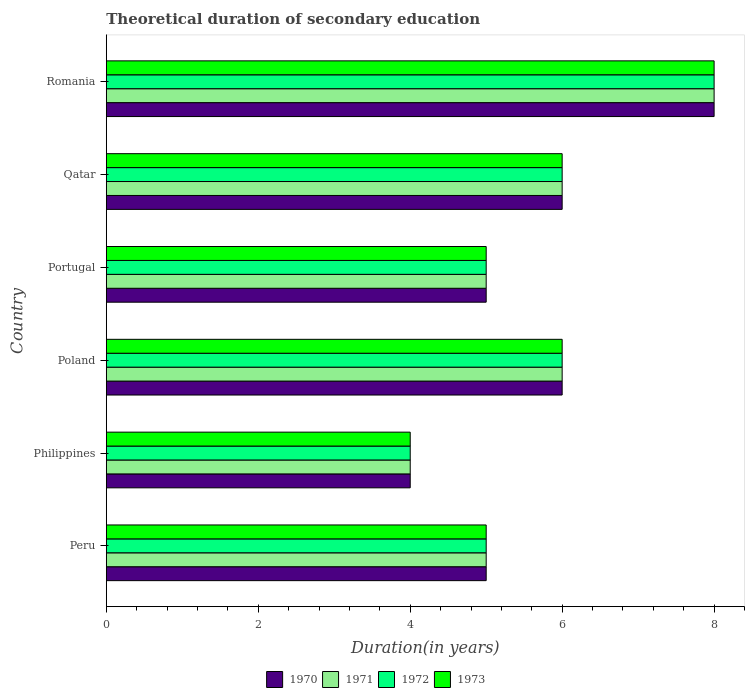How many groups of bars are there?
Provide a short and direct response. 6. Are the number of bars per tick equal to the number of legend labels?
Give a very brief answer. Yes. Are the number of bars on each tick of the Y-axis equal?
Give a very brief answer. Yes. How many bars are there on the 2nd tick from the bottom?
Make the answer very short. 4. What is the label of the 6th group of bars from the top?
Keep it short and to the point. Peru. What is the total theoretical duration of secondary education in 1973 in Poland?
Provide a short and direct response. 6. In which country was the total theoretical duration of secondary education in 1973 maximum?
Provide a short and direct response. Romania. What is the total total theoretical duration of secondary education in 1970 in the graph?
Offer a terse response. 34. What is the difference between the total theoretical duration of secondary education in 1972 in Philippines and that in Qatar?
Your answer should be very brief. -2. What is the difference between the total theoretical duration of secondary education in 1972 in Romania and the total theoretical duration of secondary education in 1971 in Philippines?
Offer a terse response. 4. What is the average total theoretical duration of secondary education in 1971 per country?
Make the answer very short. 5.67. What is the ratio of the total theoretical duration of secondary education in 1972 in Poland to that in Qatar?
Keep it short and to the point. 1. Is the total theoretical duration of secondary education in 1971 in Qatar less than that in Romania?
Your answer should be very brief. Yes. Is the difference between the total theoretical duration of secondary education in 1971 in Philippines and Poland greater than the difference between the total theoretical duration of secondary education in 1972 in Philippines and Poland?
Provide a succinct answer. No. What is the difference between the highest and the second highest total theoretical duration of secondary education in 1971?
Give a very brief answer. 2. What is the difference between the highest and the lowest total theoretical duration of secondary education in 1972?
Give a very brief answer. 4. Is the sum of the total theoretical duration of secondary education in 1973 in Poland and Romania greater than the maximum total theoretical duration of secondary education in 1972 across all countries?
Offer a terse response. Yes. Is it the case that in every country, the sum of the total theoretical duration of secondary education in 1970 and total theoretical duration of secondary education in 1971 is greater than the sum of total theoretical duration of secondary education in 1973 and total theoretical duration of secondary education in 1972?
Give a very brief answer. No. What does the 4th bar from the top in Philippines represents?
Your answer should be compact. 1970. What does the 1st bar from the bottom in Portugal represents?
Provide a short and direct response. 1970. Are all the bars in the graph horizontal?
Your response must be concise. Yes. How many countries are there in the graph?
Provide a succinct answer. 6. What is the difference between two consecutive major ticks on the X-axis?
Your answer should be compact. 2. Where does the legend appear in the graph?
Your answer should be compact. Bottom center. How many legend labels are there?
Offer a terse response. 4. How are the legend labels stacked?
Your response must be concise. Horizontal. What is the title of the graph?
Offer a terse response. Theoretical duration of secondary education. Does "1963" appear as one of the legend labels in the graph?
Provide a succinct answer. No. What is the label or title of the X-axis?
Offer a terse response. Duration(in years). What is the label or title of the Y-axis?
Provide a short and direct response. Country. What is the Duration(in years) in 1970 in Peru?
Offer a terse response. 5. What is the Duration(in years) of 1972 in Peru?
Keep it short and to the point. 5. What is the Duration(in years) of 1972 in Philippines?
Keep it short and to the point. 4. What is the Duration(in years) of 1971 in Poland?
Ensure brevity in your answer.  6. What is the Duration(in years) in 1970 in Portugal?
Your answer should be very brief. 5. What is the Duration(in years) in 1971 in Portugal?
Make the answer very short. 5. What is the Duration(in years) of 1973 in Portugal?
Your answer should be very brief. 5. What is the Duration(in years) in 1970 in Qatar?
Give a very brief answer. 6. What is the Duration(in years) of 1971 in Qatar?
Make the answer very short. 6. What is the Duration(in years) in 1972 in Qatar?
Make the answer very short. 6. What is the Duration(in years) of 1971 in Romania?
Keep it short and to the point. 8. What is the Duration(in years) of 1972 in Romania?
Your response must be concise. 8. Across all countries, what is the maximum Duration(in years) in 1972?
Offer a terse response. 8. Across all countries, what is the minimum Duration(in years) of 1970?
Ensure brevity in your answer.  4. Across all countries, what is the minimum Duration(in years) in 1971?
Provide a succinct answer. 4. Across all countries, what is the minimum Duration(in years) of 1972?
Provide a succinct answer. 4. Across all countries, what is the minimum Duration(in years) in 1973?
Keep it short and to the point. 4. What is the total Duration(in years) in 1971 in the graph?
Keep it short and to the point. 34. What is the total Duration(in years) in 1972 in the graph?
Provide a short and direct response. 34. What is the difference between the Duration(in years) in 1970 in Peru and that in Philippines?
Your answer should be very brief. 1. What is the difference between the Duration(in years) in 1972 in Peru and that in Philippines?
Provide a short and direct response. 1. What is the difference between the Duration(in years) of 1970 in Peru and that in Poland?
Ensure brevity in your answer.  -1. What is the difference between the Duration(in years) in 1971 in Peru and that in Poland?
Your response must be concise. -1. What is the difference between the Duration(in years) of 1973 in Peru and that in Poland?
Your answer should be very brief. -1. What is the difference between the Duration(in years) of 1970 in Peru and that in Portugal?
Make the answer very short. 0. What is the difference between the Duration(in years) of 1971 in Peru and that in Portugal?
Your answer should be compact. 0. What is the difference between the Duration(in years) in 1972 in Peru and that in Portugal?
Your answer should be very brief. 0. What is the difference between the Duration(in years) of 1971 in Peru and that in Qatar?
Provide a short and direct response. -1. What is the difference between the Duration(in years) of 1972 in Peru and that in Qatar?
Your answer should be very brief. -1. What is the difference between the Duration(in years) of 1970 in Peru and that in Romania?
Your answer should be compact. -3. What is the difference between the Duration(in years) in 1973 in Peru and that in Romania?
Your answer should be compact. -3. What is the difference between the Duration(in years) in 1972 in Philippines and that in Poland?
Provide a short and direct response. -2. What is the difference between the Duration(in years) in 1973 in Philippines and that in Poland?
Make the answer very short. -2. What is the difference between the Duration(in years) in 1970 in Philippines and that in Portugal?
Make the answer very short. -1. What is the difference between the Duration(in years) in 1972 in Philippines and that in Portugal?
Ensure brevity in your answer.  -1. What is the difference between the Duration(in years) of 1972 in Philippines and that in Qatar?
Provide a succinct answer. -2. What is the difference between the Duration(in years) of 1973 in Philippines and that in Qatar?
Keep it short and to the point. -2. What is the difference between the Duration(in years) of 1970 in Philippines and that in Romania?
Ensure brevity in your answer.  -4. What is the difference between the Duration(in years) in 1973 in Philippines and that in Romania?
Provide a short and direct response. -4. What is the difference between the Duration(in years) in 1971 in Poland and that in Qatar?
Give a very brief answer. 0. What is the difference between the Duration(in years) in 1971 in Poland and that in Romania?
Provide a short and direct response. -2. What is the difference between the Duration(in years) of 1971 in Portugal and that in Qatar?
Make the answer very short. -1. What is the difference between the Duration(in years) in 1970 in Portugal and that in Romania?
Make the answer very short. -3. What is the difference between the Duration(in years) in 1973 in Portugal and that in Romania?
Your response must be concise. -3. What is the difference between the Duration(in years) of 1971 in Peru and the Duration(in years) of 1973 in Philippines?
Provide a short and direct response. 1. What is the difference between the Duration(in years) in 1972 in Peru and the Duration(in years) in 1973 in Philippines?
Your response must be concise. 1. What is the difference between the Duration(in years) in 1970 in Peru and the Duration(in years) in 1972 in Poland?
Your response must be concise. -1. What is the difference between the Duration(in years) of 1970 in Peru and the Duration(in years) of 1971 in Portugal?
Offer a terse response. 0. What is the difference between the Duration(in years) in 1970 in Peru and the Duration(in years) in 1973 in Portugal?
Keep it short and to the point. 0. What is the difference between the Duration(in years) of 1971 in Peru and the Duration(in years) of 1972 in Portugal?
Your response must be concise. 0. What is the difference between the Duration(in years) in 1971 in Peru and the Duration(in years) in 1973 in Portugal?
Provide a short and direct response. 0. What is the difference between the Duration(in years) in 1972 in Peru and the Duration(in years) in 1973 in Portugal?
Offer a terse response. 0. What is the difference between the Duration(in years) of 1970 in Peru and the Duration(in years) of 1972 in Qatar?
Your answer should be very brief. -1. What is the difference between the Duration(in years) in 1970 in Peru and the Duration(in years) in 1973 in Qatar?
Keep it short and to the point. -1. What is the difference between the Duration(in years) of 1971 in Peru and the Duration(in years) of 1972 in Qatar?
Give a very brief answer. -1. What is the difference between the Duration(in years) in 1971 in Peru and the Duration(in years) in 1973 in Qatar?
Make the answer very short. -1. What is the difference between the Duration(in years) in 1972 in Peru and the Duration(in years) in 1973 in Qatar?
Your answer should be compact. -1. What is the difference between the Duration(in years) in 1970 in Peru and the Duration(in years) in 1972 in Romania?
Offer a terse response. -3. What is the difference between the Duration(in years) of 1970 in Peru and the Duration(in years) of 1973 in Romania?
Provide a succinct answer. -3. What is the difference between the Duration(in years) of 1971 in Peru and the Duration(in years) of 1973 in Romania?
Your answer should be compact. -3. What is the difference between the Duration(in years) of 1972 in Peru and the Duration(in years) of 1973 in Romania?
Your response must be concise. -3. What is the difference between the Duration(in years) of 1970 in Philippines and the Duration(in years) of 1971 in Poland?
Provide a short and direct response. -2. What is the difference between the Duration(in years) in 1970 in Philippines and the Duration(in years) in 1972 in Poland?
Your response must be concise. -2. What is the difference between the Duration(in years) in 1970 in Philippines and the Duration(in years) in 1973 in Poland?
Provide a succinct answer. -2. What is the difference between the Duration(in years) of 1971 in Philippines and the Duration(in years) of 1973 in Poland?
Offer a terse response. -2. What is the difference between the Duration(in years) of 1972 in Philippines and the Duration(in years) of 1973 in Poland?
Provide a succinct answer. -2. What is the difference between the Duration(in years) in 1970 in Philippines and the Duration(in years) in 1973 in Portugal?
Your answer should be compact. -1. What is the difference between the Duration(in years) of 1971 in Philippines and the Duration(in years) of 1973 in Portugal?
Your answer should be compact. -1. What is the difference between the Duration(in years) of 1970 in Philippines and the Duration(in years) of 1971 in Qatar?
Offer a very short reply. -2. What is the difference between the Duration(in years) in 1970 in Philippines and the Duration(in years) in 1973 in Qatar?
Keep it short and to the point. -2. What is the difference between the Duration(in years) of 1971 in Philippines and the Duration(in years) of 1972 in Qatar?
Your answer should be compact. -2. What is the difference between the Duration(in years) of 1970 in Philippines and the Duration(in years) of 1971 in Romania?
Offer a terse response. -4. What is the difference between the Duration(in years) of 1970 in Philippines and the Duration(in years) of 1973 in Romania?
Offer a terse response. -4. What is the difference between the Duration(in years) of 1971 in Philippines and the Duration(in years) of 1973 in Romania?
Provide a succinct answer. -4. What is the difference between the Duration(in years) in 1970 in Poland and the Duration(in years) in 1972 in Portugal?
Ensure brevity in your answer.  1. What is the difference between the Duration(in years) of 1970 in Poland and the Duration(in years) of 1973 in Portugal?
Provide a short and direct response. 1. What is the difference between the Duration(in years) of 1972 in Poland and the Duration(in years) of 1973 in Portugal?
Your answer should be compact. 1. What is the difference between the Duration(in years) in 1970 in Poland and the Duration(in years) in 1971 in Qatar?
Offer a terse response. 0. What is the difference between the Duration(in years) in 1971 in Poland and the Duration(in years) in 1973 in Qatar?
Your response must be concise. 0. What is the difference between the Duration(in years) of 1970 in Poland and the Duration(in years) of 1971 in Romania?
Keep it short and to the point. -2. What is the difference between the Duration(in years) of 1970 in Poland and the Duration(in years) of 1973 in Romania?
Provide a short and direct response. -2. What is the difference between the Duration(in years) in 1971 in Poland and the Duration(in years) in 1973 in Romania?
Offer a terse response. -2. What is the difference between the Duration(in years) in 1970 in Portugal and the Duration(in years) in 1971 in Qatar?
Your answer should be compact. -1. What is the difference between the Duration(in years) in 1970 in Portugal and the Duration(in years) in 1972 in Qatar?
Your response must be concise. -1. What is the difference between the Duration(in years) of 1970 in Portugal and the Duration(in years) of 1973 in Qatar?
Your answer should be compact. -1. What is the difference between the Duration(in years) of 1971 in Portugal and the Duration(in years) of 1972 in Qatar?
Offer a terse response. -1. What is the difference between the Duration(in years) in 1970 in Portugal and the Duration(in years) in 1971 in Romania?
Offer a very short reply. -3. What is the difference between the Duration(in years) of 1971 in Portugal and the Duration(in years) of 1972 in Romania?
Give a very brief answer. -3. What is the difference between the Duration(in years) of 1972 in Portugal and the Duration(in years) of 1973 in Romania?
Ensure brevity in your answer.  -3. What is the difference between the Duration(in years) of 1970 in Qatar and the Duration(in years) of 1971 in Romania?
Ensure brevity in your answer.  -2. What is the difference between the Duration(in years) in 1970 in Qatar and the Duration(in years) in 1972 in Romania?
Keep it short and to the point. -2. What is the difference between the Duration(in years) in 1970 in Qatar and the Duration(in years) in 1973 in Romania?
Give a very brief answer. -2. What is the difference between the Duration(in years) of 1971 in Qatar and the Duration(in years) of 1973 in Romania?
Keep it short and to the point. -2. What is the difference between the Duration(in years) of 1972 in Qatar and the Duration(in years) of 1973 in Romania?
Give a very brief answer. -2. What is the average Duration(in years) in 1970 per country?
Keep it short and to the point. 5.67. What is the average Duration(in years) in 1971 per country?
Offer a terse response. 5.67. What is the average Duration(in years) in 1972 per country?
Make the answer very short. 5.67. What is the average Duration(in years) in 1973 per country?
Your response must be concise. 5.67. What is the difference between the Duration(in years) in 1970 and Duration(in years) in 1971 in Peru?
Keep it short and to the point. 0. What is the difference between the Duration(in years) in 1970 and Duration(in years) in 1972 in Philippines?
Offer a very short reply. 0. What is the difference between the Duration(in years) of 1971 and Duration(in years) of 1972 in Philippines?
Keep it short and to the point. 0. What is the difference between the Duration(in years) in 1971 and Duration(in years) in 1973 in Philippines?
Your response must be concise. 0. What is the difference between the Duration(in years) of 1972 and Duration(in years) of 1973 in Philippines?
Provide a succinct answer. 0. What is the difference between the Duration(in years) in 1970 and Duration(in years) in 1973 in Poland?
Give a very brief answer. 0. What is the difference between the Duration(in years) in 1971 and Duration(in years) in 1973 in Poland?
Offer a terse response. 0. What is the difference between the Duration(in years) of 1971 and Duration(in years) of 1973 in Portugal?
Your answer should be very brief. 0. What is the difference between the Duration(in years) of 1972 and Duration(in years) of 1973 in Portugal?
Your answer should be very brief. 0. What is the difference between the Duration(in years) in 1970 and Duration(in years) in 1972 in Qatar?
Provide a short and direct response. 0. What is the difference between the Duration(in years) in 1970 and Duration(in years) in 1973 in Qatar?
Your answer should be compact. 0. What is the difference between the Duration(in years) of 1971 and Duration(in years) of 1973 in Qatar?
Provide a short and direct response. 0. What is the difference between the Duration(in years) in 1970 and Duration(in years) in 1971 in Romania?
Ensure brevity in your answer.  0. What is the difference between the Duration(in years) in 1971 and Duration(in years) in 1973 in Romania?
Offer a terse response. 0. What is the ratio of the Duration(in years) of 1970 in Peru to that in Philippines?
Your answer should be very brief. 1.25. What is the ratio of the Duration(in years) of 1972 in Peru to that in Philippines?
Keep it short and to the point. 1.25. What is the ratio of the Duration(in years) of 1970 in Peru to that in Poland?
Your response must be concise. 0.83. What is the ratio of the Duration(in years) of 1971 in Peru to that in Poland?
Ensure brevity in your answer.  0.83. What is the ratio of the Duration(in years) in 1973 in Peru to that in Poland?
Make the answer very short. 0.83. What is the ratio of the Duration(in years) of 1972 in Peru to that in Portugal?
Offer a terse response. 1. What is the ratio of the Duration(in years) of 1970 in Peru to that in Qatar?
Ensure brevity in your answer.  0.83. What is the ratio of the Duration(in years) of 1971 in Peru to that in Qatar?
Your response must be concise. 0.83. What is the ratio of the Duration(in years) of 1970 in Peru to that in Romania?
Make the answer very short. 0.62. What is the ratio of the Duration(in years) in 1971 in Peru to that in Romania?
Ensure brevity in your answer.  0.62. What is the ratio of the Duration(in years) of 1972 in Peru to that in Romania?
Your answer should be compact. 0.62. What is the ratio of the Duration(in years) in 1973 in Peru to that in Romania?
Ensure brevity in your answer.  0.62. What is the ratio of the Duration(in years) in 1970 in Philippines to that in Portugal?
Provide a short and direct response. 0.8. What is the ratio of the Duration(in years) in 1971 in Philippines to that in Portugal?
Your answer should be compact. 0.8. What is the ratio of the Duration(in years) of 1972 in Philippines to that in Portugal?
Your answer should be compact. 0.8. What is the ratio of the Duration(in years) of 1973 in Philippines to that in Portugal?
Offer a terse response. 0.8. What is the ratio of the Duration(in years) in 1970 in Philippines to that in Qatar?
Your answer should be compact. 0.67. What is the ratio of the Duration(in years) in 1971 in Philippines to that in Qatar?
Keep it short and to the point. 0.67. What is the ratio of the Duration(in years) of 1973 in Philippines to that in Qatar?
Ensure brevity in your answer.  0.67. What is the ratio of the Duration(in years) of 1971 in Philippines to that in Romania?
Offer a terse response. 0.5. What is the ratio of the Duration(in years) in 1973 in Philippines to that in Romania?
Offer a very short reply. 0.5. What is the ratio of the Duration(in years) in 1970 in Poland to that in Portugal?
Your response must be concise. 1.2. What is the ratio of the Duration(in years) of 1972 in Poland to that in Portugal?
Your answer should be compact. 1.2. What is the ratio of the Duration(in years) of 1973 in Poland to that in Portugal?
Your answer should be very brief. 1.2. What is the ratio of the Duration(in years) of 1971 in Poland to that in Qatar?
Your answer should be compact. 1. What is the ratio of the Duration(in years) of 1972 in Poland to that in Qatar?
Ensure brevity in your answer.  1. What is the ratio of the Duration(in years) in 1973 in Poland to that in Qatar?
Your response must be concise. 1. What is the ratio of the Duration(in years) in 1972 in Poland to that in Romania?
Offer a very short reply. 0.75. What is the ratio of the Duration(in years) in 1972 in Portugal to that in Qatar?
Provide a short and direct response. 0.83. What is the ratio of the Duration(in years) in 1973 in Portugal to that in Qatar?
Offer a very short reply. 0.83. What is the ratio of the Duration(in years) of 1972 in Portugal to that in Romania?
Offer a very short reply. 0.62. What is the ratio of the Duration(in years) in 1970 in Qatar to that in Romania?
Offer a very short reply. 0.75. What is the difference between the highest and the second highest Duration(in years) in 1972?
Make the answer very short. 2. What is the difference between the highest and the lowest Duration(in years) in 1973?
Make the answer very short. 4. 